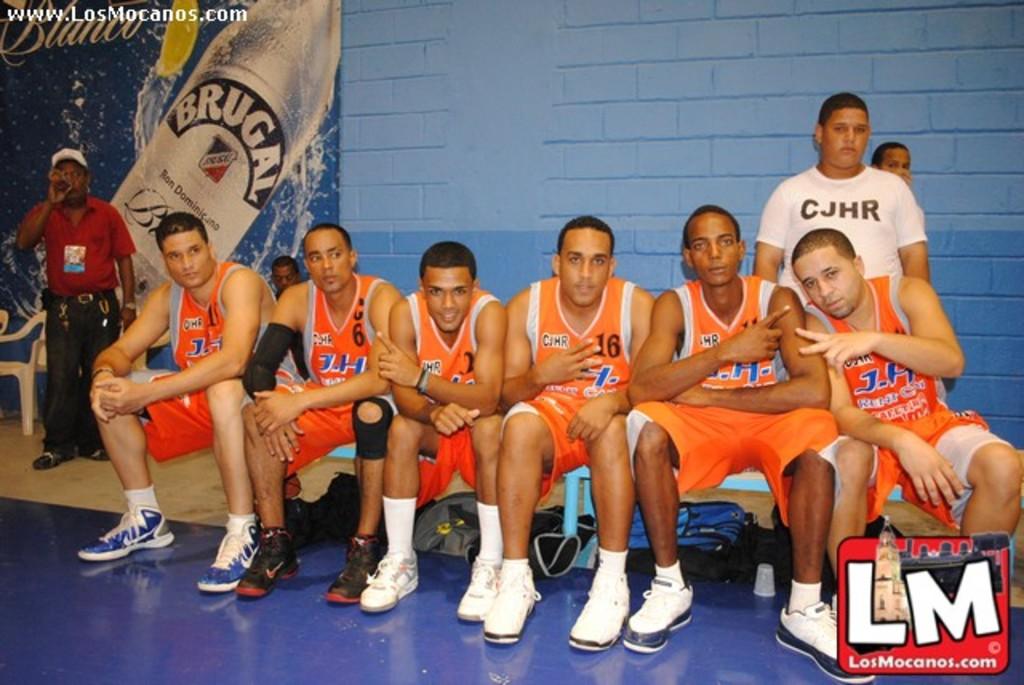What is the name of this team?
Your answer should be compact. Los mocanos. What is on the middle players jersey?
Make the answer very short. 16. 